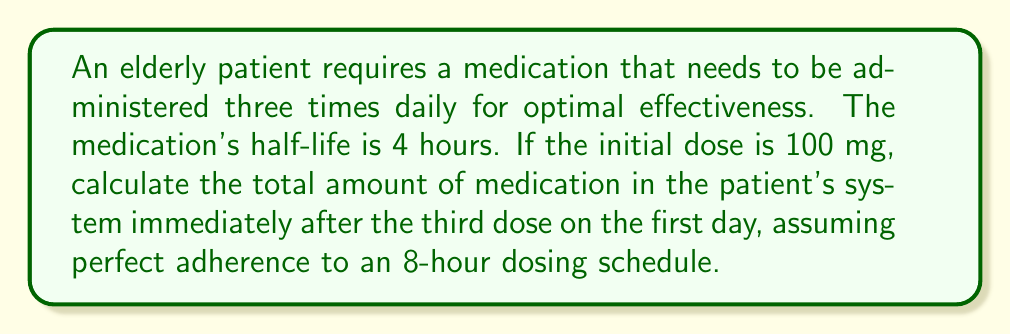Can you solve this math problem? Let's approach this step-by-step:

1) First, we need to understand the dosing schedule:
   - Dose 1: 0 hours (initial)
   - Dose 2: 8 hours later
   - Dose 3: 16 hours after initial dose

2) We'll use the exponential decay formula to calculate the remaining amount of each dose:
   $A(t) = A_0 \cdot (\frac{1}{2})^{t/t_{1/2}}$
   Where:
   $A(t)$ is the amount remaining after time $t$
   $A_0$ is the initial amount
   $t$ is the time elapsed
   $t_{1/2}$ is the half-life

3) Let's calculate the remaining amount from each dose:

   Dose 1 (after 16 hours):
   $A_1 = 100 \cdot (\frac{1}{2})^{16/4} = 100 \cdot (\frac{1}{2})^4 = 6.25$ mg

   Dose 2 (after 8 hours):
   $A_2 = 100 \cdot (\frac{1}{2})^{8/4} = 100 \cdot (\frac{1}{2})^2 = 25$ mg

   Dose 3 (just administered):
   $A_3 = 100$ mg

4) The total amount in the system is the sum of these three:
   $A_{total} = A_1 + A_2 + A_3 = 6.25 + 25 + 100 = 131.25$ mg
Answer: 131.25 mg 